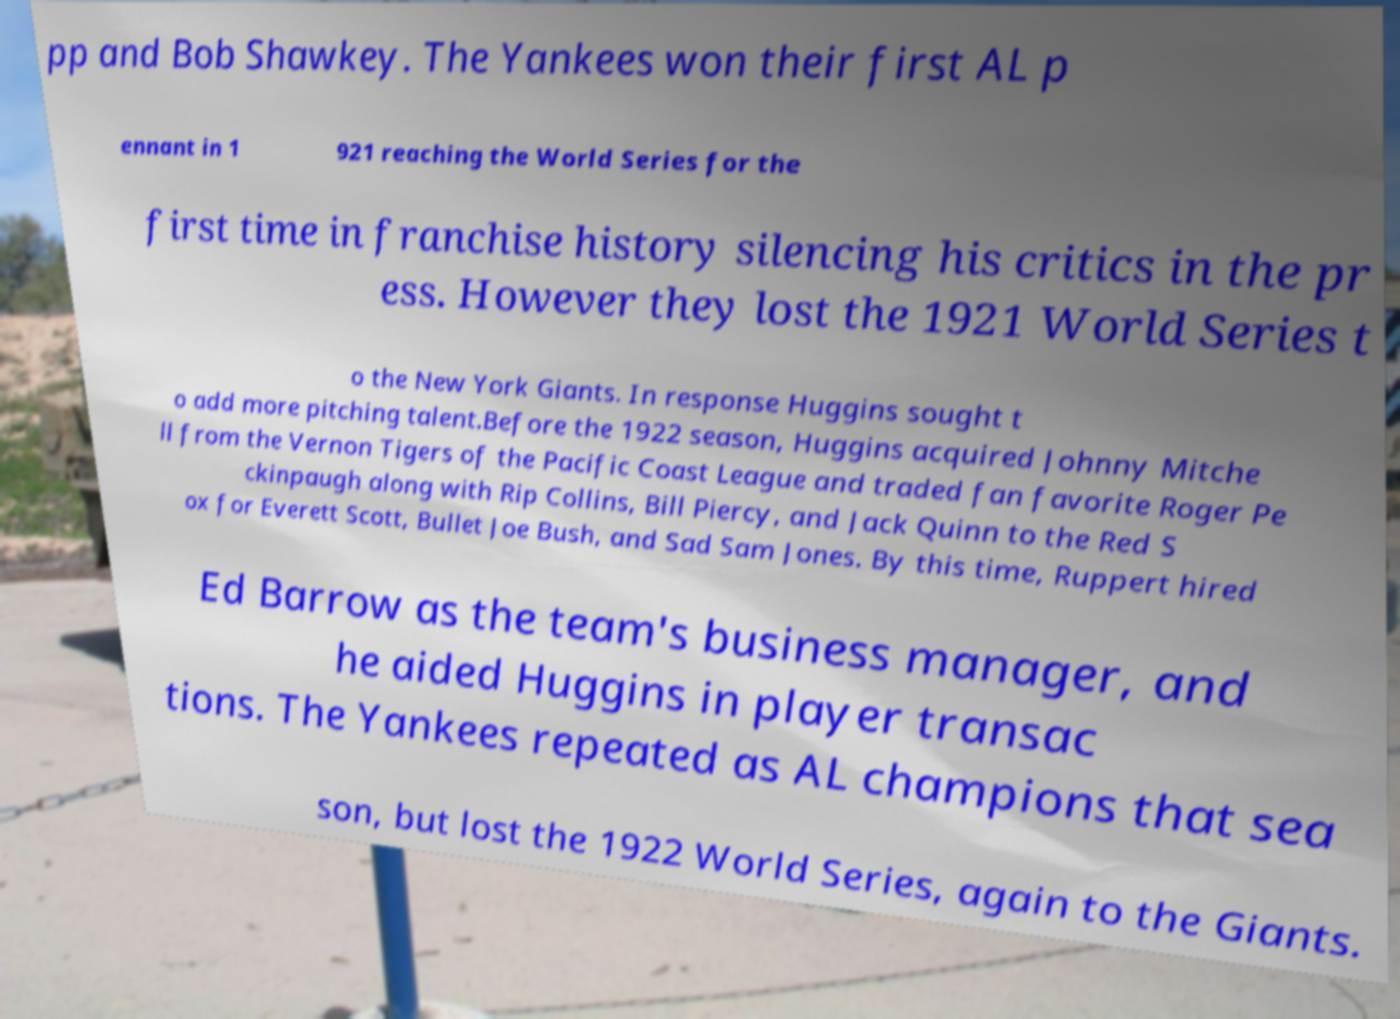Please read and relay the text visible in this image. What does it say? pp and Bob Shawkey. The Yankees won their first AL p ennant in 1 921 reaching the World Series for the first time in franchise history silencing his critics in the pr ess. However they lost the 1921 World Series t o the New York Giants. In response Huggins sought t o add more pitching talent.Before the 1922 season, Huggins acquired Johnny Mitche ll from the Vernon Tigers of the Pacific Coast League and traded fan favorite Roger Pe ckinpaugh along with Rip Collins, Bill Piercy, and Jack Quinn to the Red S ox for Everett Scott, Bullet Joe Bush, and Sad Sam Jones. By this time, Ruppert hired Ed Barrow as the team's business manager, and he aided Huggins in player transac tions. The Yankees repeated as AL champions that sea son, but lost the 1922 World Series, again to the Giants. 